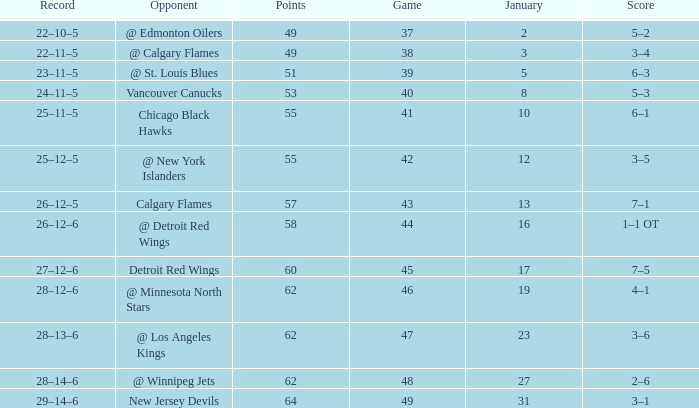How many Games have a Score of 2–6, and Points larger than 62? 0.0. 